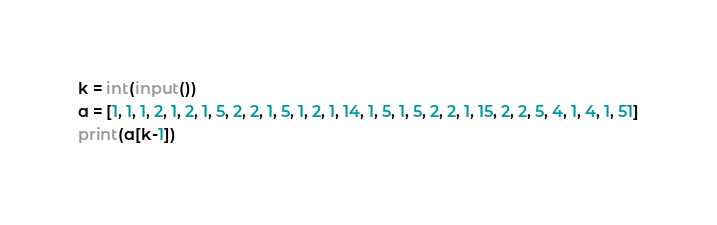<code> <loc_0><loc_0><loc_500><loc_500><_Python_>k = int(input())
a = [1, 1, 1, 2, 1, 2, 1, 5, 2, 2, 1, 5, 1, 2, 1, 14, 1, 5, 1, 5, 2, 2, 1, 15, 2, 2, 5, 4, 1, 4, 1, 51]
print(a[k-1])
</code> 